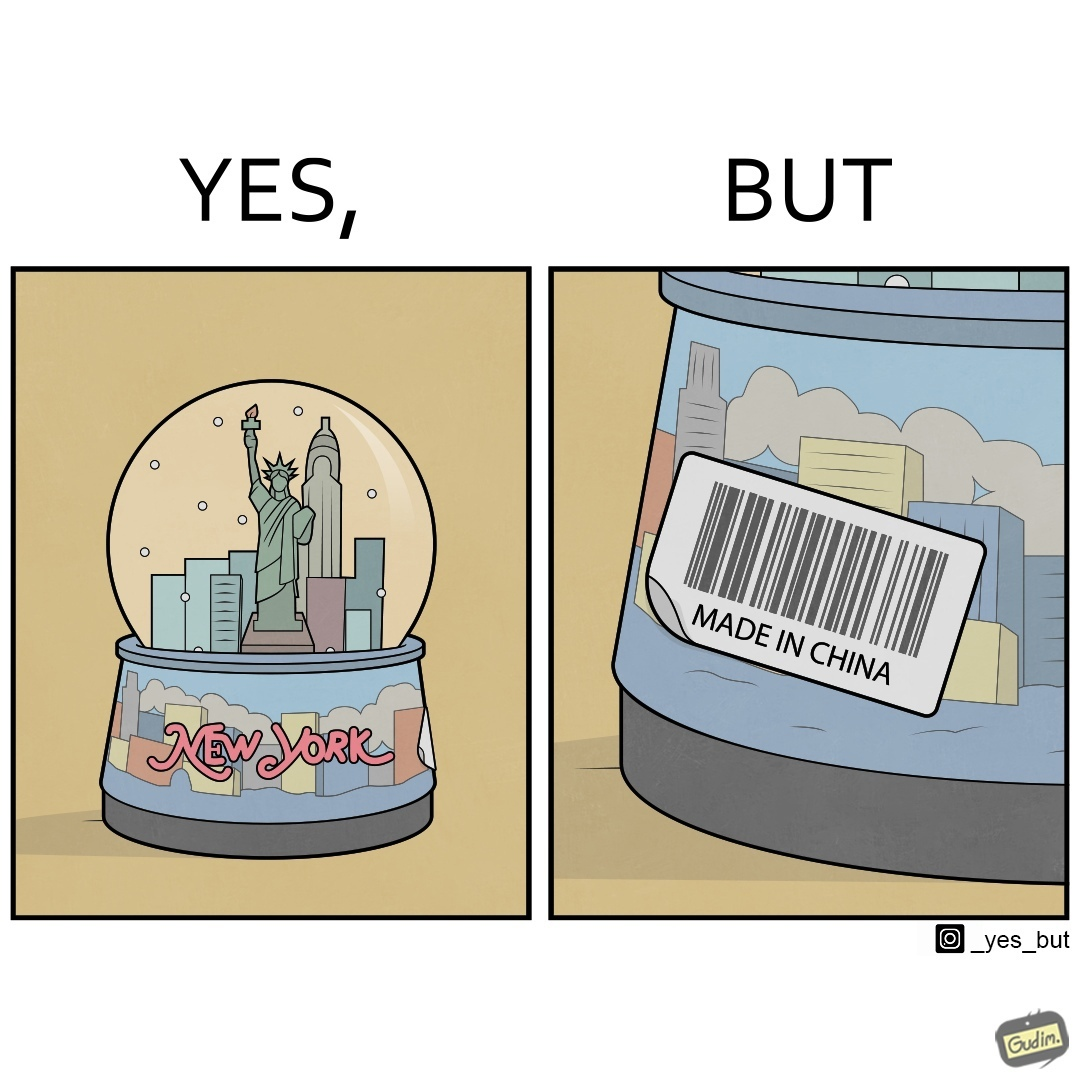Explain the humor or irony in this image. The image is ironic because the snowglobe says 'New York' while it is made in China 